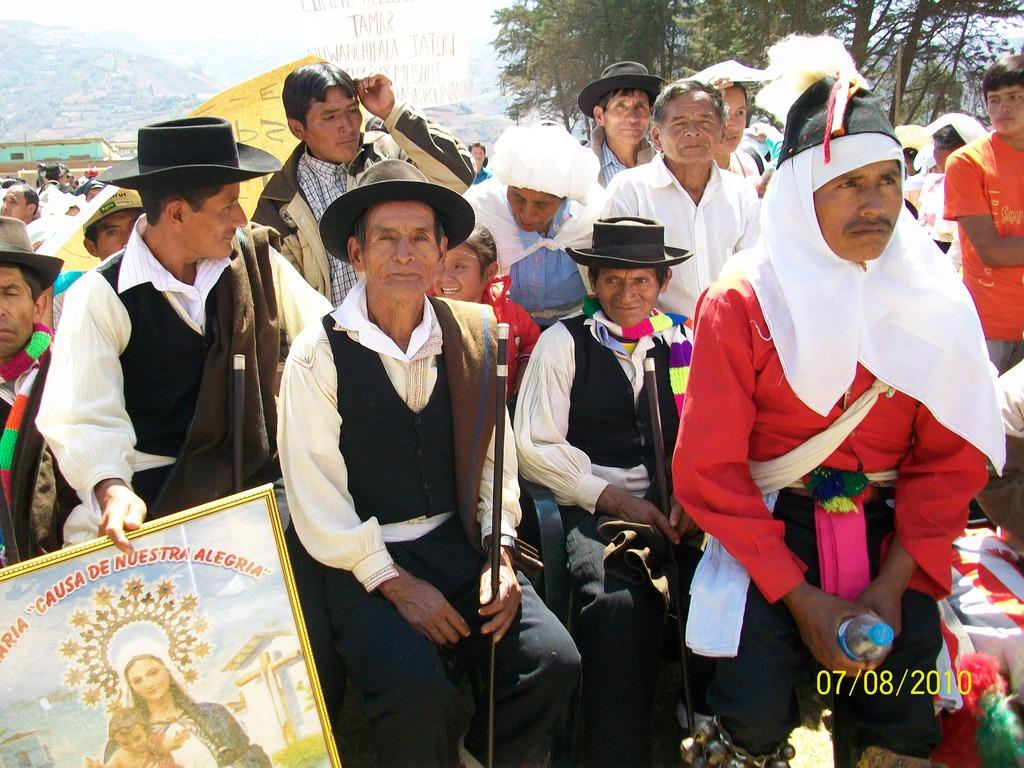What are the people in the image doing? There are people sitting in the image, and some of them are holding sticks and banners. What objects can be seen in the hands of the people in the image? Some people are holding sticks and banners in the image. What type of decorative item is present in the image? There is a photo frame in the image. What information is provided in the bottom right corner of the image? A date is present in the bottom right corner of the image. What type of natural landscape can be seen in the image? Mountains are visible in the image. Where is the faucet located in the image? There is no faucet present in the image. How does the stream flow in the image? There is no stream present in the image. 